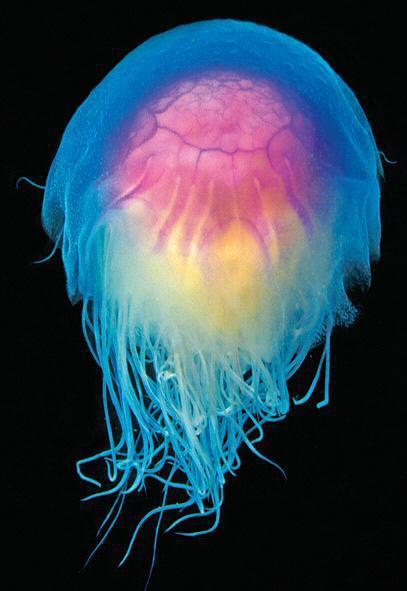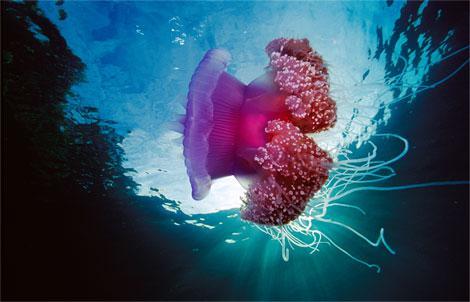The first image is the image on the left, the second image is the image on the right. For the images shown, is this caption "All the organisms have long tentacles." true? Answer yes or no. Yes. The first image is the image on the left, the second image is the image on the right. For the images displayed, is the sentence "Each image shows one jellyfish, and one image shows a translucent blue jellyfish with lavender and cream colored interior parts showing, and stringy tentacles trailing nearly straight downward." factually correct? Answer yes or no. Yes. 